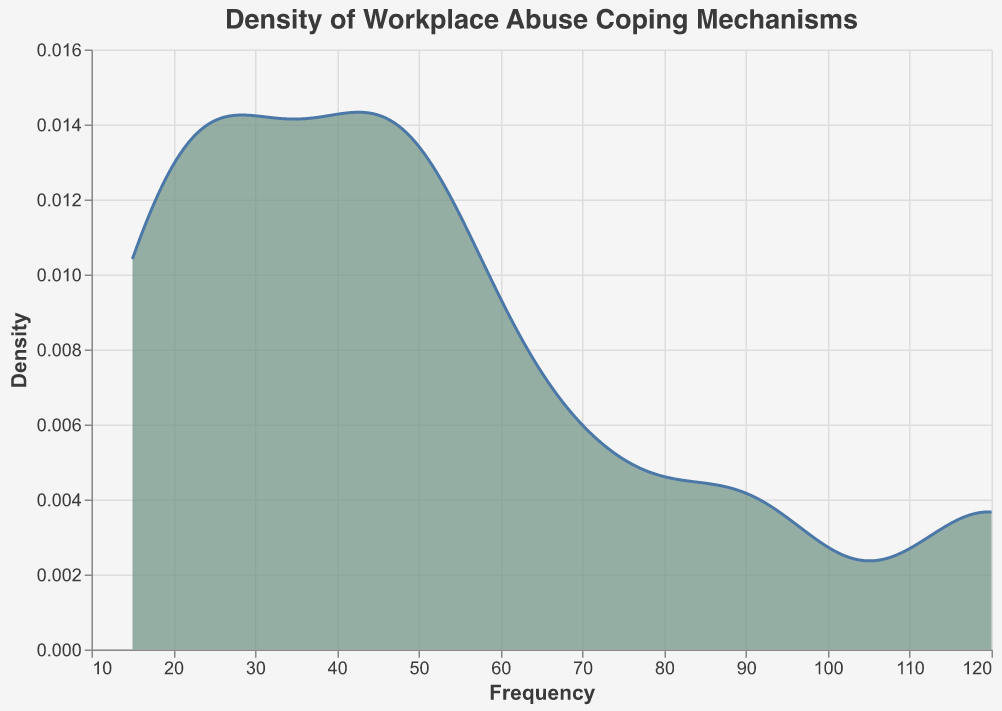What is the title of the plot? The title of the plot is displayed at the top in large font to indicate what the plot is about. It helps viewers understand the context of the data being visualized.
Answer: Density of Workplace Abuse Coping Mechanisms What is the unit on the X-axis? The X-axis represents the Frequency of different coping mechanisms used for workplace abuse, and this is labeled as "Frequency."
Answer: Frequency What is the peak (highest point) density value on the plot? To find the peak density value, look for the highest point on the Y-axis in the plot, which represents the density.
Answer: The exact peak value is not provided, but the highest point can be identified visually on the plot Which coping mechanism has the highest frequency? The coping mechanism with the highest frequency will have the largest value on the X-axis, which can be identified from the dataset or plotted points.
Answer: Talking to Friends or Family What is the mean frequency of all coping mechanisms combined? To find the mean, sum all frequencies (120+40+90+70+50+30+15+45+25+55+20=560) and divide by the number of coping mechanisms (11). Mean frequency = 560 / 11.
Answer: 50.91 Which coping mechanism has the lowest frequency? The coping mechanism with the lowest frequency can be identified by looking at the smallest value on the X-axis in the data inset or directly from the plot annotations.
Answer: Seeking Legal Advice Compare the frequency of Exercise and Meditation/Yoga. Which one is more common? Compare the frequency values for Exercise (90) and Meditation/Yoga (70) from the data or plot points. Exercise has a higher frequency.
Answer: Exercise What is the approximate density value at a frequency of 50? Locate the position at frequency 50 on the X-axis and move upwards to the corresponding density on the Y-axis. The value is approximate.
Answer: The density value at 50 is around 0.012 (depends on the exact scale and smoothing) What are the coping mechanisms with a frequency greater than 40 but less than 70? List the coping mechanisms within the frequency range by checking the dataset or the points in that range on the plot. They are Taking Time Off (50), Documenting Abuse (45), and Researching Better Communication Strategies (55).
Answer: Taking Time Off, Documenting Abuse, Researching Better Communication Strategies 